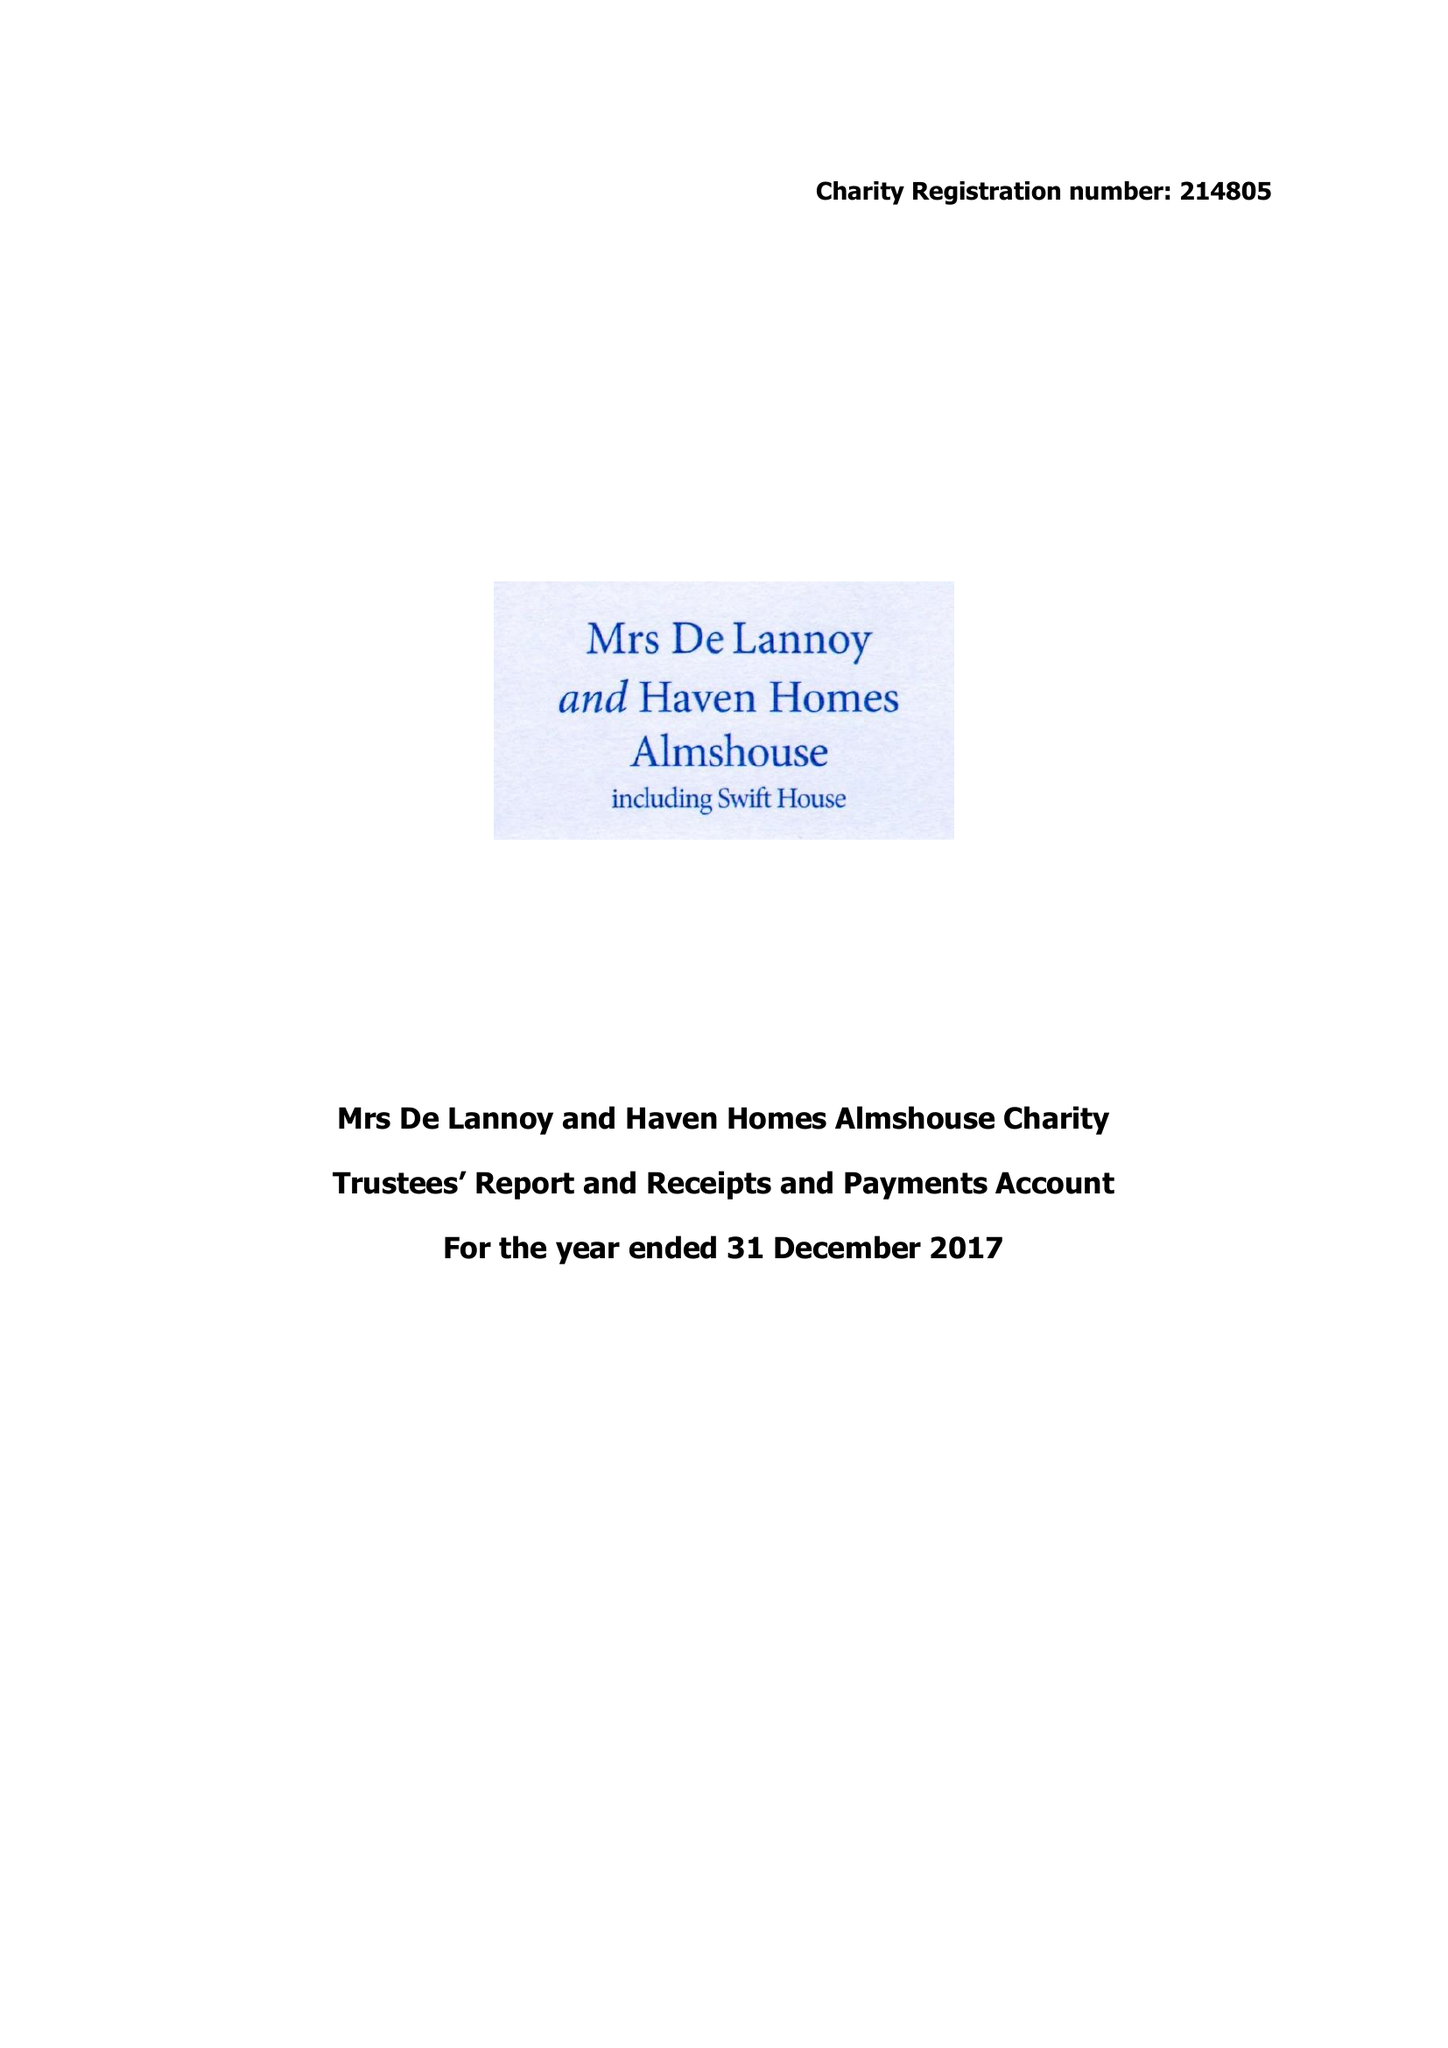What is the value for the charity_number?
Answer the question using a single word or phrase. 214805 